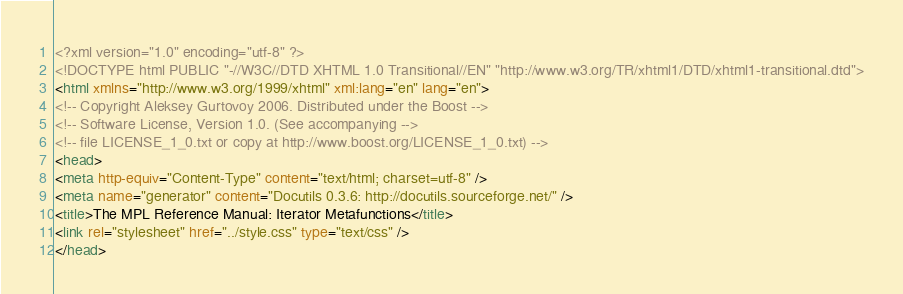Convert code to text. <code><loc_0><loc_0><loc_500><loc_500><_HTML_><?xml version="1.0" encoding="utf-8" ?>
<!DOCTYPE html PUBLIC "-//W3C//DTD XHTML 1.0 Transitional//EN" "http://www.w3.org/TR/xhtml1/DTD/xhtml1-transitional.dtd">
<html xmlns="http://www.w3.org/1999/xhtml" xml:lang="en" lang="en">
<!-- Copyright Aleksey Gurtovoy 2006. Distributed under the Boost -->
<!-- Software License, Version 1.0. (See accompanying -->
<!-- file LICENSE_1_0.txt or copy at http://www.boost.org/LICENSE_1_0.txt) -->
<head>
<meta http-equiv="Content-Type" content="text/html; charset=utf-8" />
<meta name="generator" content="Docutils 0.3.6: http://docutils.sourceforge.net/" />
<title>The MPL Reference Manual: Iterator Metafunctions</title>
<link rel="stylesheet" href="../style.css" type="text/css" />
</head></code> 